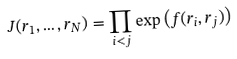Convert formula to latex. <formula><loc_0><loc_0><loc_500><loc_500>J ( r _ { 1 } , \dots , r _ { N } ) = \prod _ { i < j } \exp \left ( f ( r _ { i } , r _ { j } ) \right )</formula> 